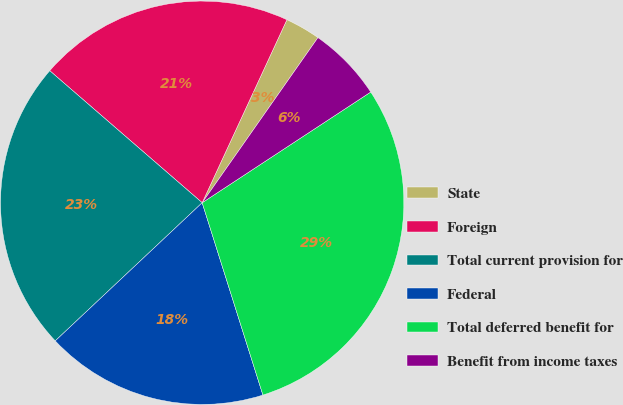Convert chart. <chart><loc_0><loc_0><loc_500><loc_500><pie_chart><fcel>State<fcel>Foreign<fcel>Total current provision for<fcel>Federal<fcel>Total deferred benefit for<fcel>Benefit from income taxes<nl><fcel>2.83%<fcel>20.54%<fcel>23.37%<fcel>17.86%<fcel>29.38%<fcel>6.02%<nl></chart> 